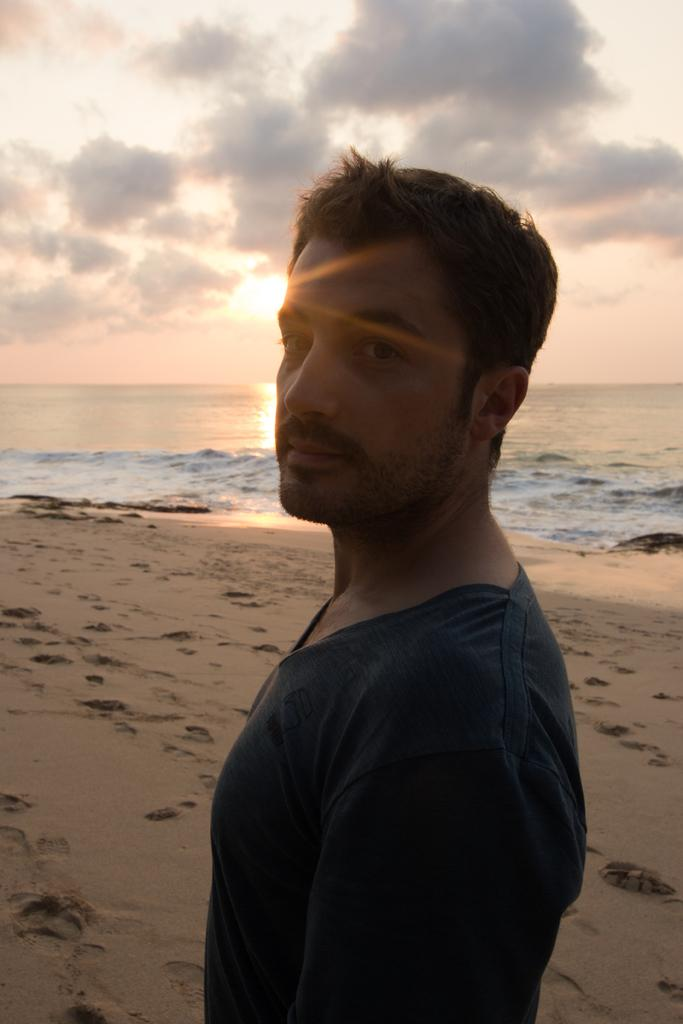What is the main subject in the front of the image? There is a man standing in the front of the image. What type of surface is at the bottom of the image? There is soil at the bottom of the image. What can be seen in the background of the image? There is water visible in the background of the image. What is visible at the top of the image? The sky is visible at the top of the image. What can be observed in the sky? Clouds are present in the sky. What type of books is the man reading in the image? There is no book or reading activity present in the image; the man is simply standing. How many trucks can be seen in the image? There are no trucks visible in the image. 